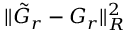Convert formula to latex. <formula><loc_0><loc_0><loc_500><loc_500>\| \tilde { G } _ { r } - G _ { r } \| _ { R } ^ { 2 }</formula> 